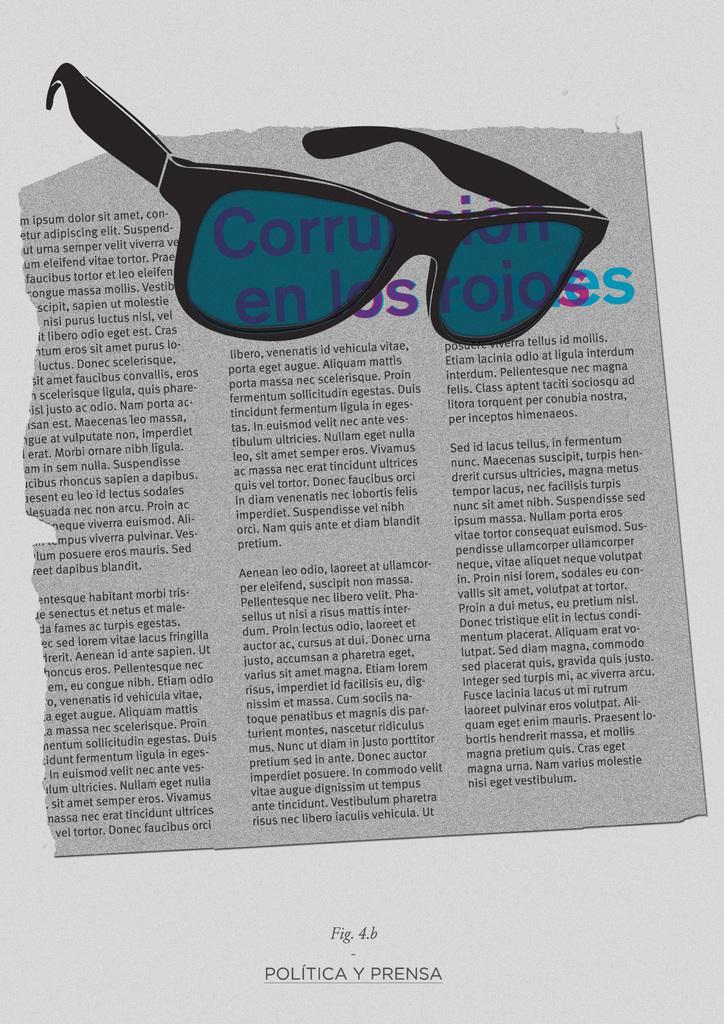Could you give a brief overview of what you see in this image? This is a paper. In this picture we can see the text and goggles. 